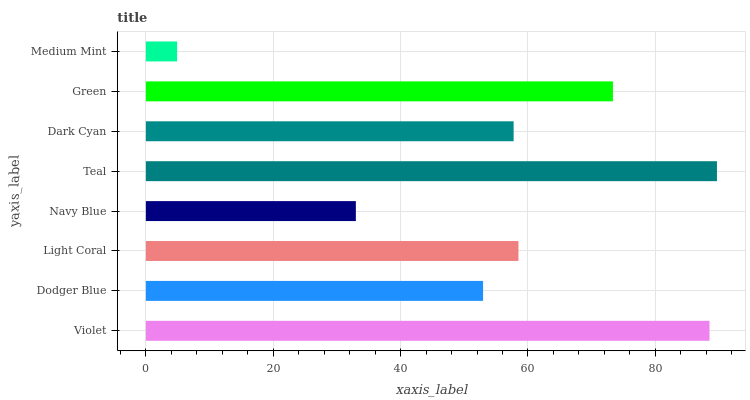Is Medium Mint the minimum?
Answer yes or no. Yes. Is Teal the maximum?
Answer yes or no. Yes. Is Dodger Blue the minimum?
Answer yes or no. No. Is Dodger Blue the maximum?
Answer yes or no. No. Is Violet greater than Dodger Blue?
Answer yes or no. Yes. Is Dodger Blue less than Violet?
Answer yes or no. Yes. Is Dodger Blue greater than Violet?
Answer yes or no. No. Is Violet less than Dodger Blue?
Answer yes or no. No. Is Light Coral the high median?
Answer yes or no. Yes. Is Dark Cyan the low median?
Answer yes or no. Yes. Is Dodger Blue the high median?
Answer yes or no. No. Is Light Coral the low median?
Answer yes or no. No. 